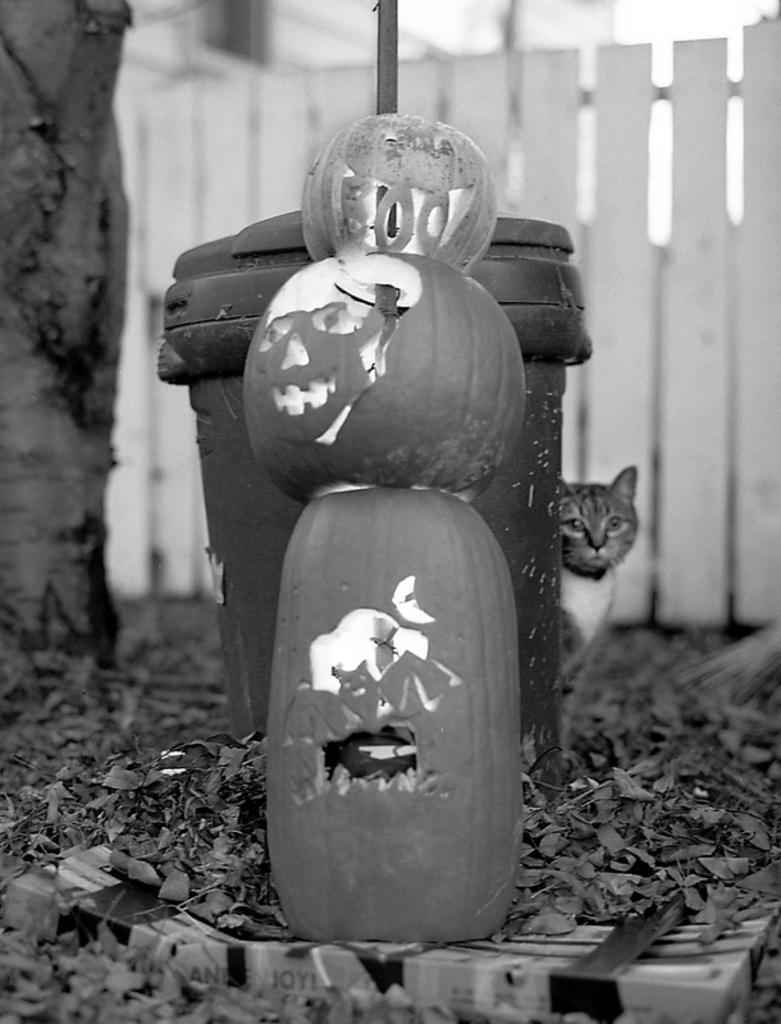Can you describe this image briefly? This is the black and white image and we can see few carved pumpkins and behind there is an object which looks like a dustbin and we can see a cat. There are some dry leaves and some other things on the ground and we can see a tree trunk and there is a fence in the background. 